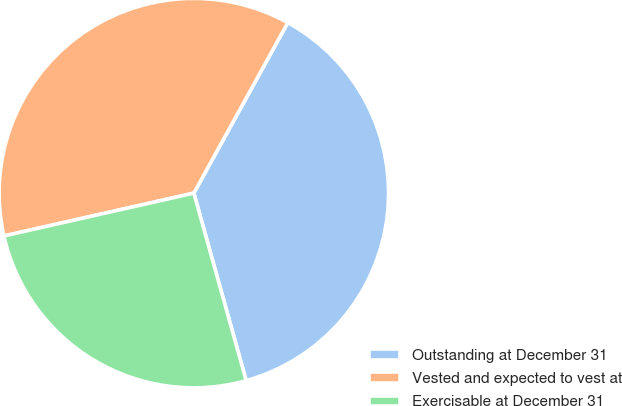<chart> <loc_0><loc_0><loc_500><loc_500><pie_chart><fcel>Outstanding at December 31<fcel>Vested and expected to vest at<fcel>Exercisable at December 31<nl><fcel>37.65%<fcel>36.55%<fcel>25.8%<nl></chart> 